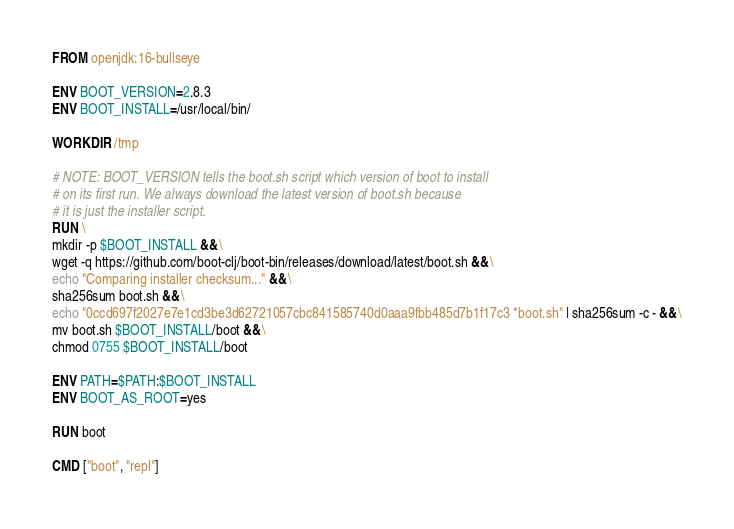Convert code to text. <code><loc_0><loc_0><loc_500><loc_500><_Dockerfile_>FROM openjdk:16-bullseye

ENV BOOT_VERSION=2.8.3
ENV BOOT_INSTALL=/usr/local/bin/

WORKDIR /tmp

# NOTE: BOOT_VERSION tells the boot.sh script which version of boot to install
# on its first run. We always download the latest version of boot.sh because
# it is just the installer script.
RUN \
mkdir -p $BOOT_INSTALL && \
wget -q https://github.com/boot-clj/boot-bin/releases/download/latest/boot.sh && \
echo "Comparing installer checksum..." && \
sha256sum boot.sh && \
echo "0ccd697f2027e7e1cd3be3d62721057cbc841585740d0aaa9fbb485d7b1f17c3 *boot.sh" | sha256sum -c - && \
mv boot.sh $BOOT_INSTALL/boot && \
chmod 0755 $BOOT_INSTALL/boot

ENV PATH=$PATH:$BOOT_INSTALL
ENV BOOT_AS_ROOT=yes

RUN boot

CMD ["boot", "repl"]</code> 